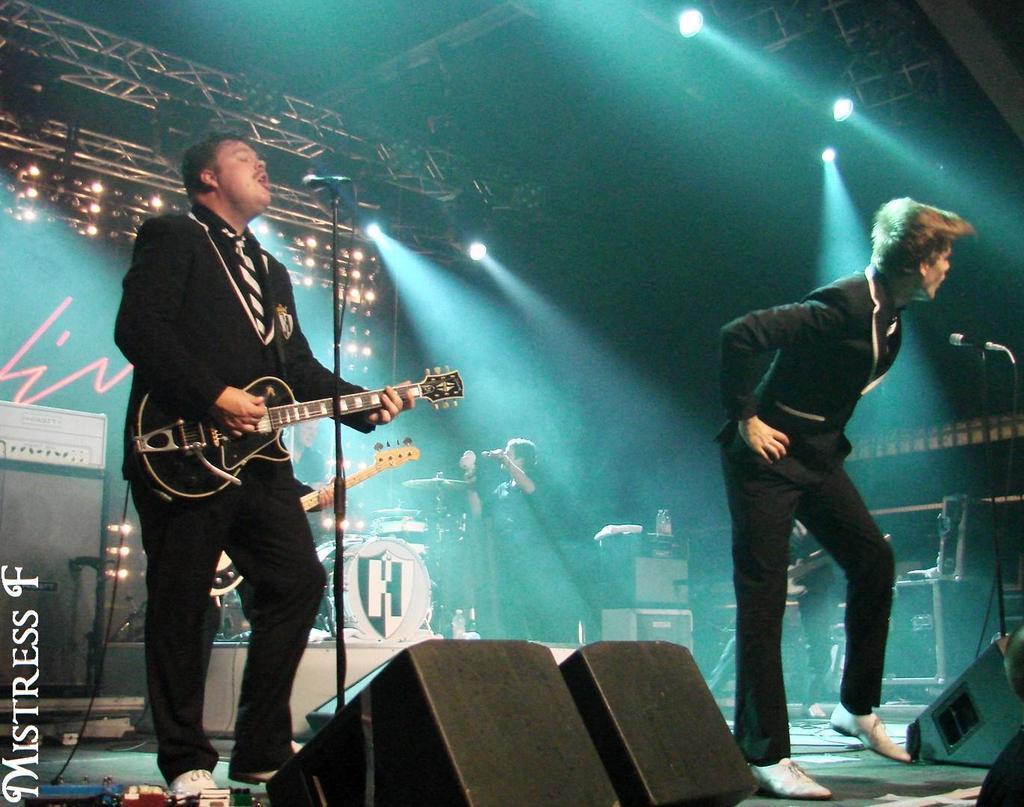Can you describe this image briefly? I can see in this image there are two men, on the left side the man is playing guitar in his hand in front of a microphone, on the right side a man is standing on the stage. 